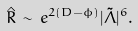Convert formula to latex. <formula><loc_0><loc_0><loc_500><loc_500>\hat { R } \, \sim \, e ^ { 2 ( D - \phi ) } | \tilde { \Lambda } | ^ { 6 } .</formula> 